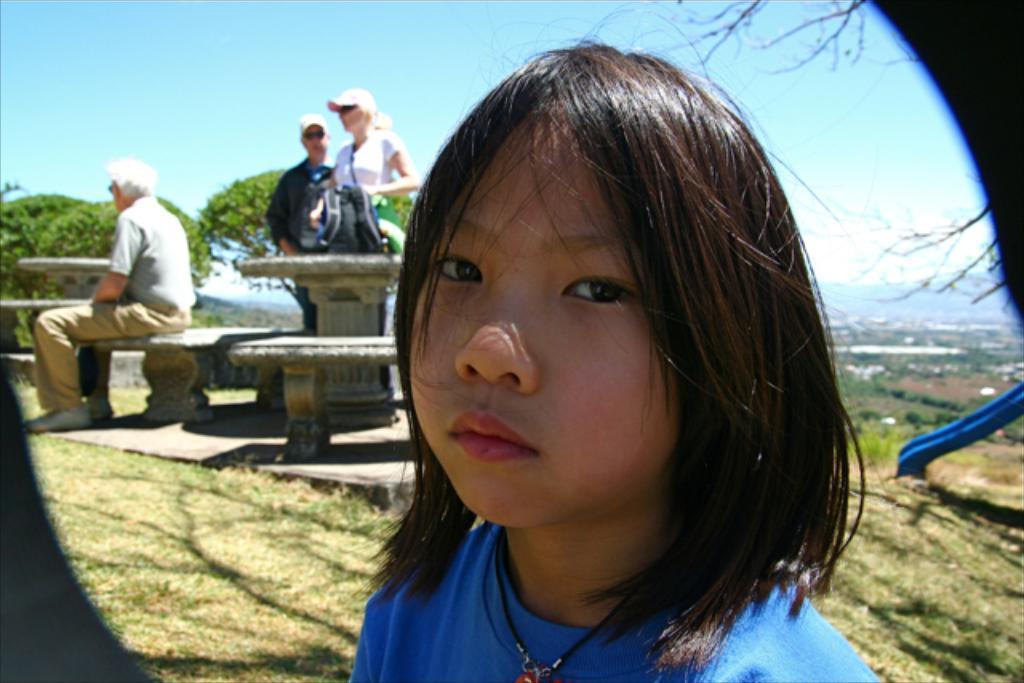Can you describe this image briefly? In this picture there is a girl who has short hair and in blue tee shirt and behind her there are three people who are blurred and we can see some plants and grass on the floor. 